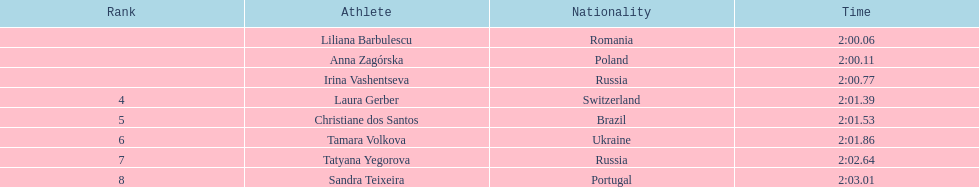Which athletes competed in the 2003 summer universiade - women's 800 metres? Liliana Barbulescu, Anna Zagórska, Irina Vashentseva, Laura Gerber, Christiane dos Santos, Tamara Volkova, Tatyana Yegorova, Sandra Teixeira. Of these, which are from poland? Anna Zagórska. What is her time? 2:00.11. 